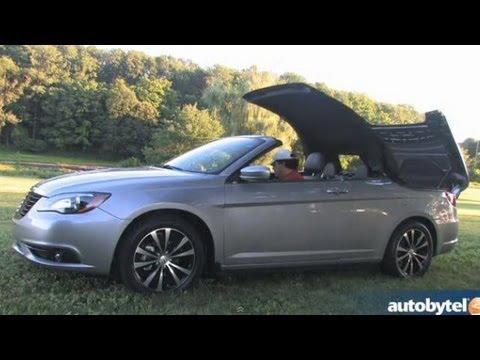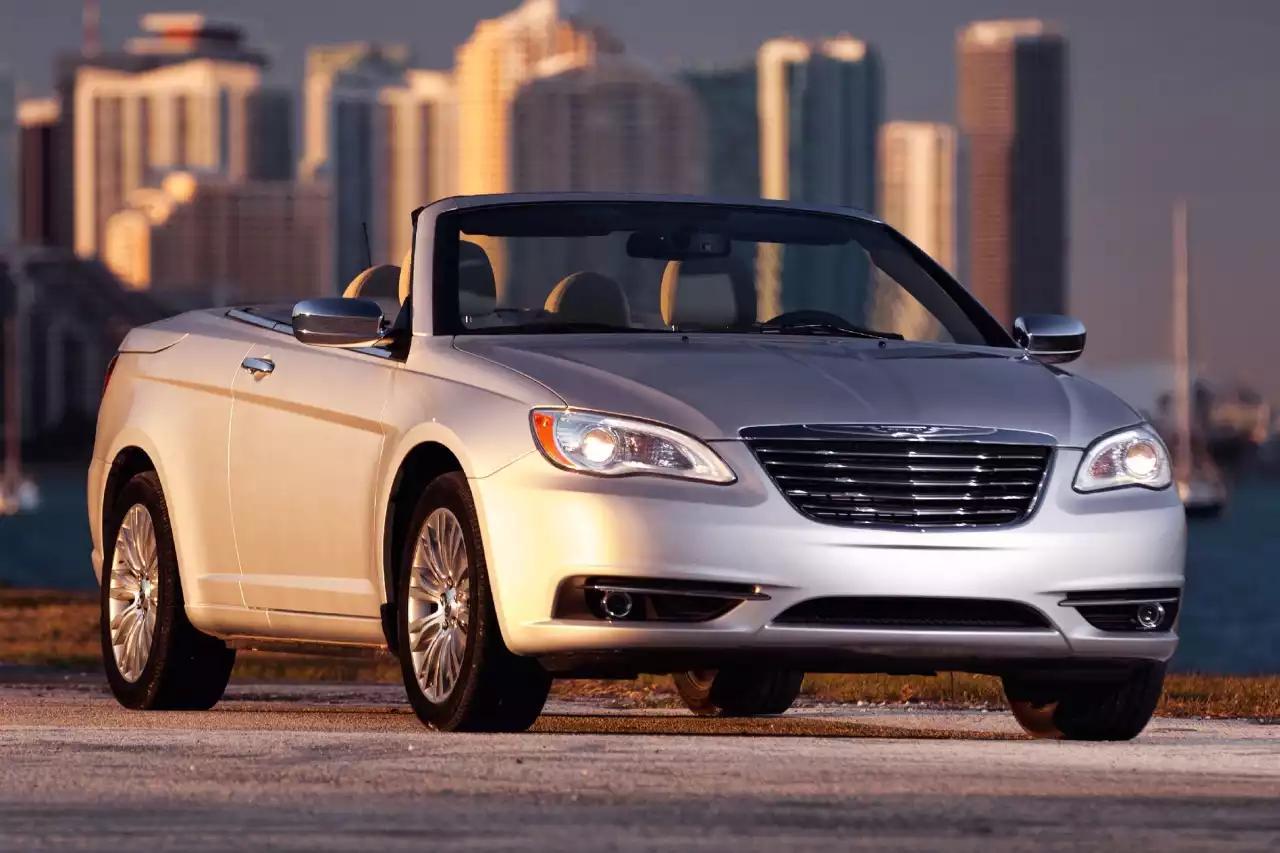The first image is the image on the left, the second image is the image on the right. For the images displayed, is the sentence "One parked car has it's top fully open, and the other parked car has it's hood fully closed." factually correct? Answer yes or no. No. The first image is the image on the left, the second image is the image on the right. For the images displayed, is the sentence "The car in the image on the right has a top." factually correct? Answer yes or no. No. 